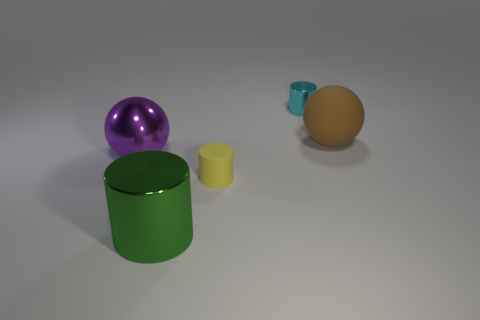Add 1 red matte cylinders. How many objects exist? 6 Subtract all tiny rubber cylinders. How many cylinders are left? 2 Subtract all brown balls. How many balls are left? 1 Subtract all gray cylinders. How many cyan spheres are left? 0 Add 5 tiny cylinders. How many tiny cylinders are left? 7 Add 3 big shiny cylinders. How many big shiny cylinders exist? 4 Subtract 0 gray cubes. How many objects are left? 5 Subtract all cylinders. How many objects are left? 2 Subtract 1 spheres. How many spheres are left? 1 Subtract all brown balls. Subtract all yellow cylinders. How many balls are left? 1 